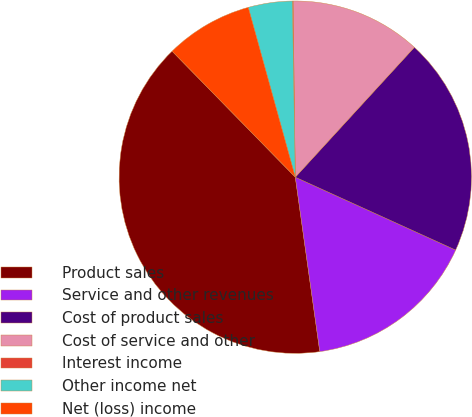<chart> <loc_0><loc_0><loc_500><loc_500><pie_chart><fcel>Product sales<fcel>Service and other revenues<fcel>Cost of product sales<fcel>Cost of service and other<fcel>Interest income<fcel>Other income net<fcel>Net (loss) income<nl><fcel>39.9%<fcel>15.99%<fcel>19.98%<fcel>12.01%<fcel>0.06%<fcel>4.04%<fcel>8.02%<nl></chart> 